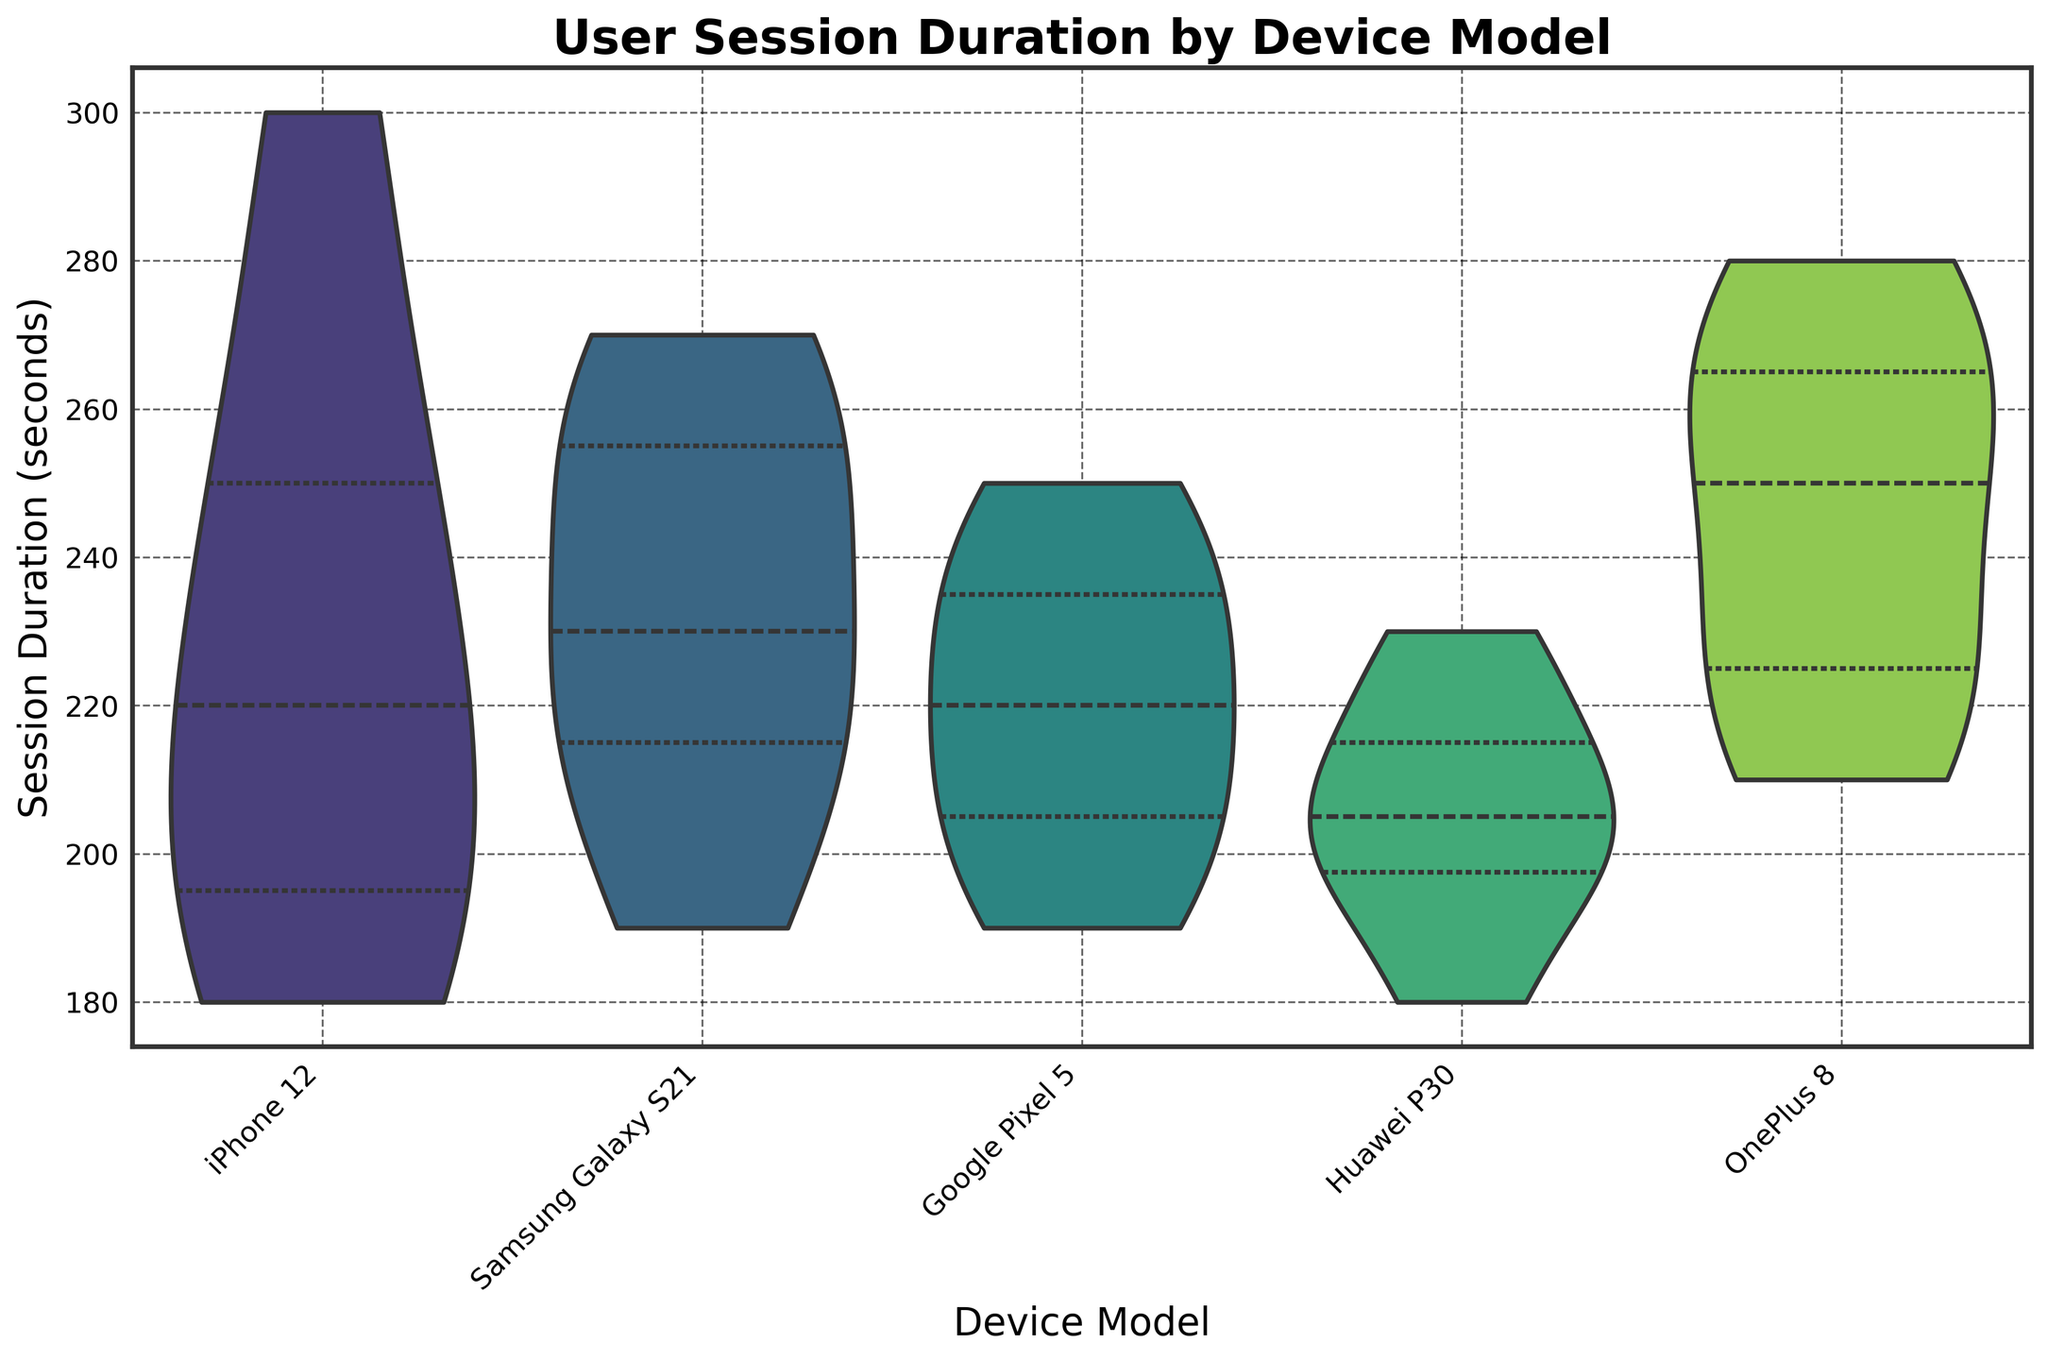What does the title of the figure indicate? The title of the figure, "User Session Duration by Device Model," indicates that the chart shows the user session duration data segmented by different device models.
Answer: User Session Duration by Device Model Which device model has the widest range in session duration? To identify the device with the widest range in session duration, observe the spread of each violin plot. The OnePlus 8 model has the widest range, extending from its lowest point to its highest point.
Answer: OnePlus 8 What is the median session duration for Google Pixel 5? Median values are indicated by the white dots within each violin plot. For Google Pixel 5, the white dot is around the 220 seconds mark.
Answer: 220 seconds Which device model shows the highest median session duration? The highest median session duration can be identified by looking at the position of the white dots in each violin plot. The OnePlus 8 shows the highest median session duration.
Answer: OnePlus 8 Which device model has the most ‘compact’ distribution of session durations? A more ‘compact’ distribution appears narrower. Huawei P30’s plot is the narrowest in terms of spread compared to other models.
Answer: Huawei P30 Compare the session durations of iPhone 12 and Samsung Galaxy S21. Which one has a higher average session duration? To compare, look at the central tendency (median or the bulk of the data). Both have a similar spread but observing the placement of white dots, Samsung Galaxy S21 generally shows a slightly higher median and average durations.
Answer: Samsung Galaxy S21 What's the difference between the highest and lowest session duration for the Huawei P30? Identify the highest and lowest points for Huawei P30's violin plot. The highest point is around 230 seconds, and the lowest point is around 180 seconds. The difference is 230 - 180.
Answer: 50 seconds What quartiles are shown within the violin plots? The inner box within each violin plot shows the interquartile range (IQR), representing the 25th to 75th percentiles.
Answer: 25th to 75th percentiles Which device model has the highest and lowest observed session duration? By looking at the extremities of each violin plot, the highest observed session duration is with OnePlus 8 (around 280 seconds), and the lowest is with Huawei P30 (around 180 seconds).
Answer: Highest: OnePlus 8, Lowest: Huawei P30 